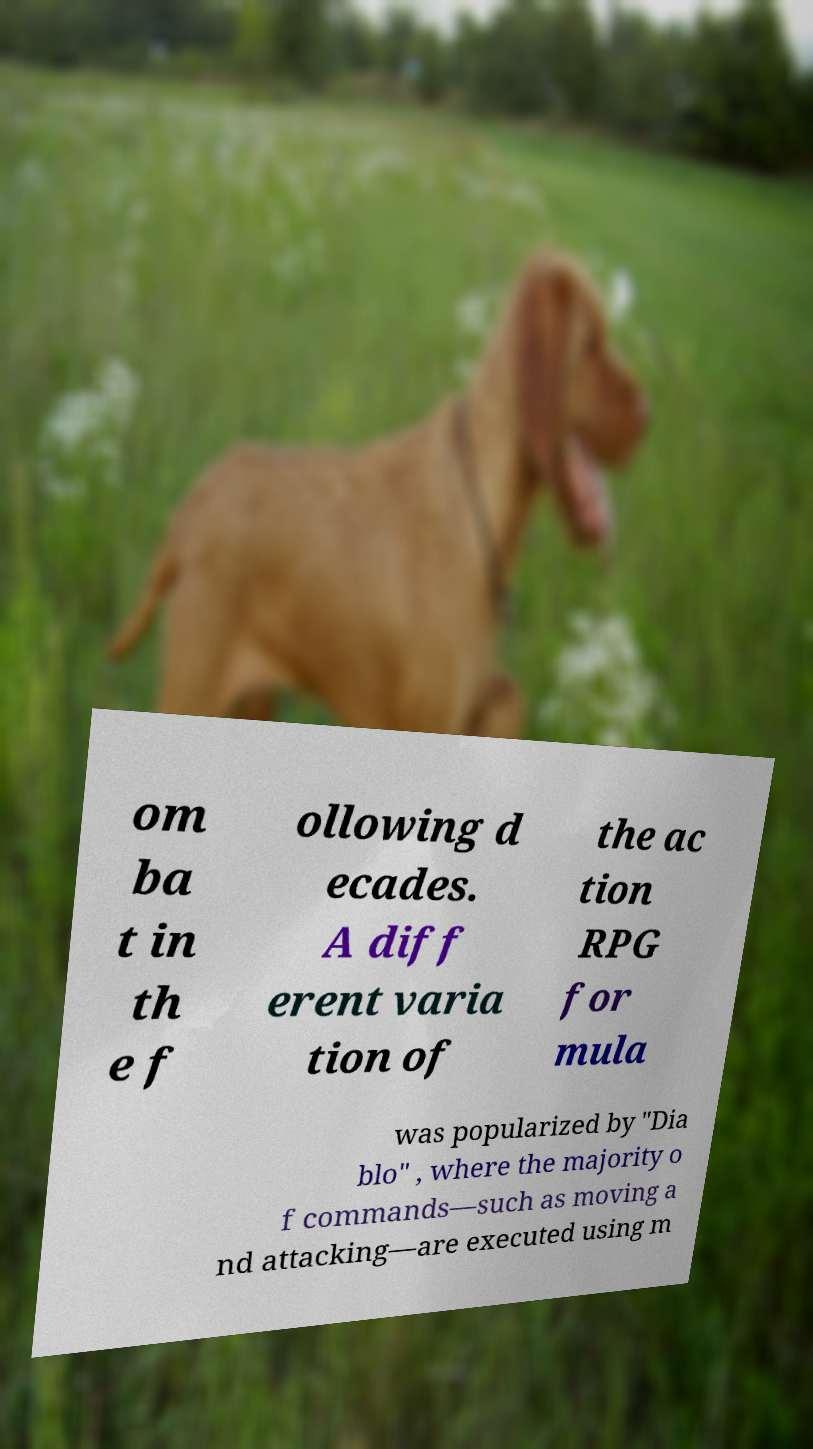What messages or text are displayed in this image? I need them in a readable, typed format. om ba t in th e f ollowing d ecades. A diff erent varia tion of the ac tion RPG for mula was popularized by "Dia blo" , where the majority o f commands—such as moving a nd attacking—are executed using m 